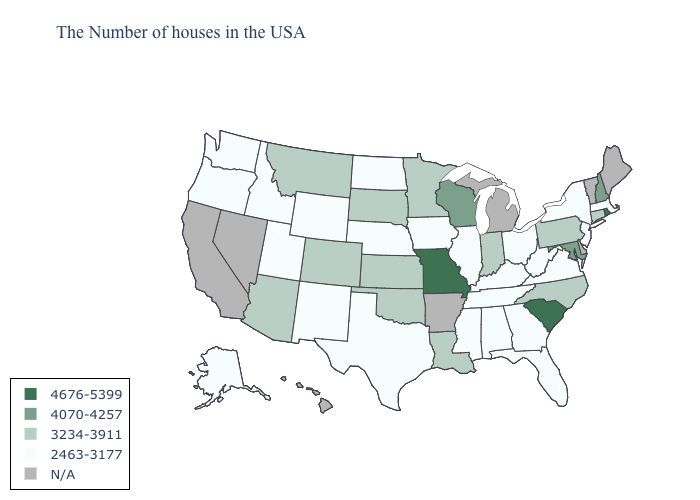Name the states that have a value in the range 2463-3177?
Concise answer only. Massachusetts, New York, New Jersey, Virginia, West Virginia, Ohio, Florida, Georgia, Kentucky, Alabama, Tennessee, Illinois, Mississippi, Iowa, Nebraska, Texas, North Dakota, Wyoming, New Mexico, Utah, Idaho, Washington, Oregon, Alaska. What is the value of Washington?
Be succinct. 2463-3177. What is the highest value in the West ?
Concise answer only. 3234-3911. Does Missouri have the highest value in the MidWest?
Keep it brief. Yes. Name the states that have a value in the range 2463-3177?
Keep it brief. Massachusetts, New York, New Jersey, Virginia, West Virginia, Ohio, Florida, Georgia, Kentucky, Alabama, Tennessee, Illinois, Mississippi, Iowa, Nebraska, Texas, North Dakota, Wyoming, New Mexico, Utah, Idaho, Washington, Oregon, Alaska. Name the states that have a value in the range 4676-5399?
Be succinct. Rhode Island, South Carolina, Missouri. What is the value of Louisiana?
Keep it brief. 3234-3911. Is the legend a continuous bar?
Short answer required. No. Is the legend a continuous bar?
Quick response, please. No. What is the value of South Dakota?
Quick response, please. 3234-3911. What is the value of Montana?
Quick response, please. 3234-3911. Does Minnesota have the highest value in the MidWest?
Concise answer only. No. Which states have the lowest value in the USA?
Be succinct. Massachusetts, New York, New Jersey, Virginia, West Virginia, Ohio, Florida, Georgia, Kentucky, Alabama, Tennessee, Illinois, Mississippi, Iowa, Nebraska, Texas, North Dakota, Wyoming, New Mexico, Utah, Idaho, Washington, Oregon, Alaska. What is the value of California?
Keep it brief. N/A. 